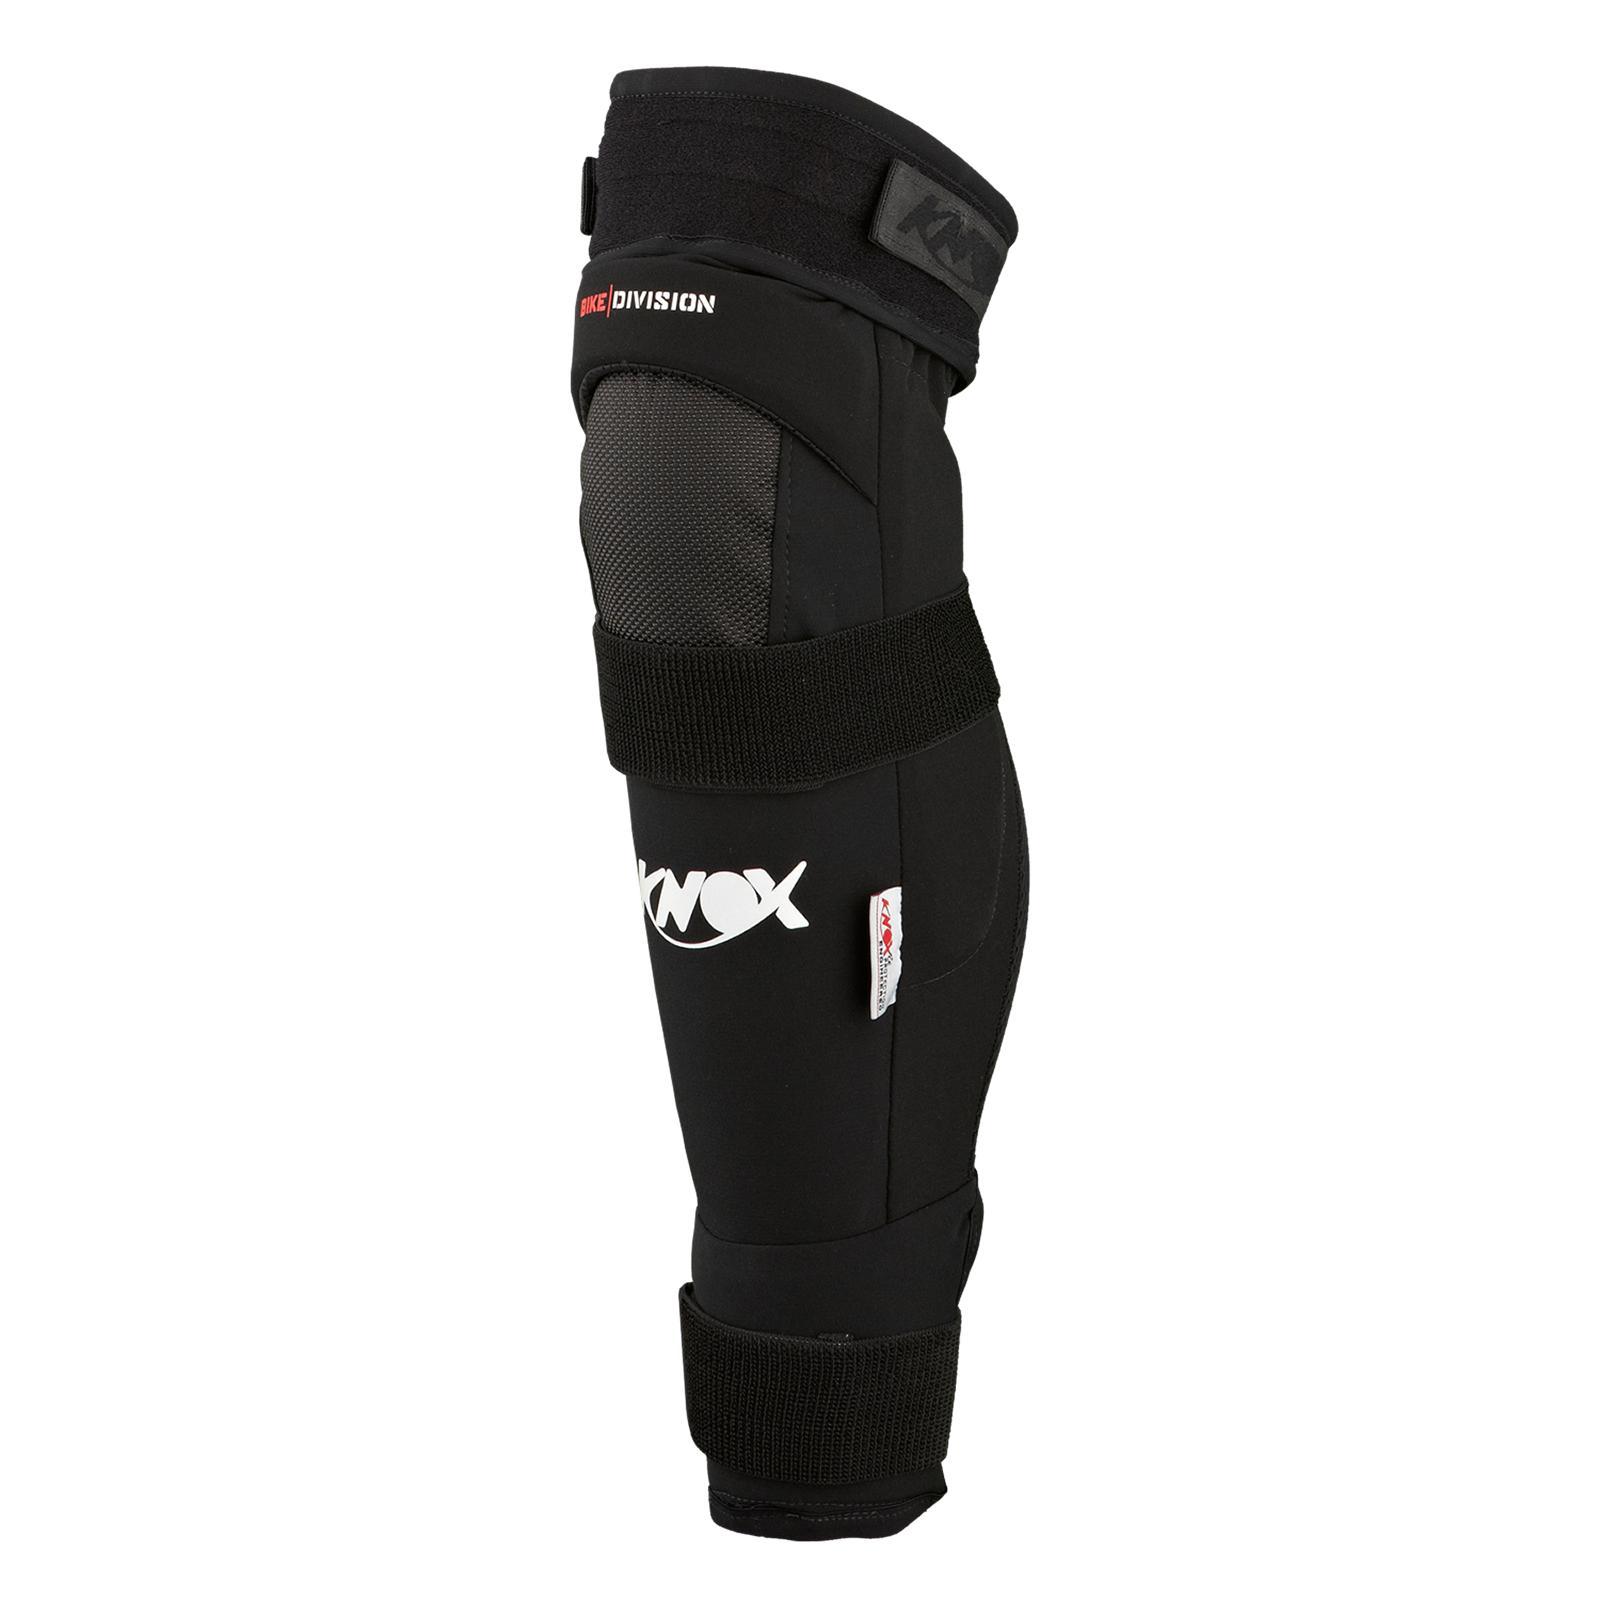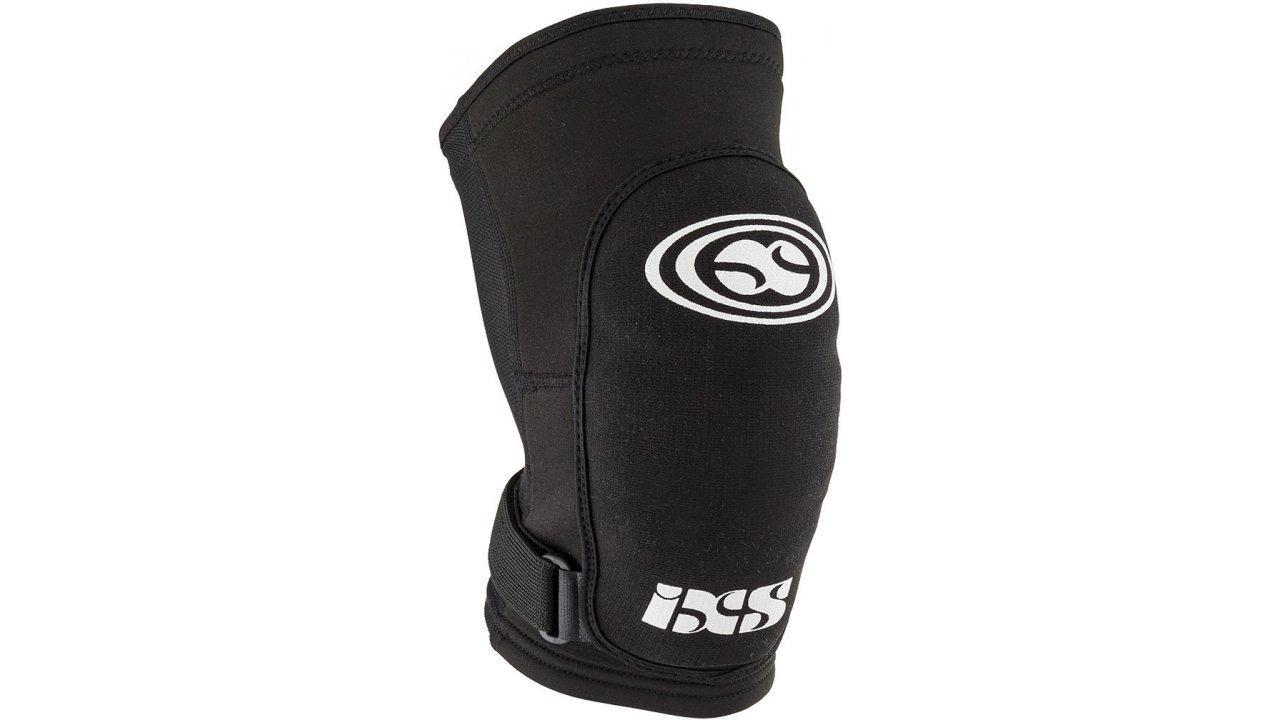The first image is the image on the left, the second image is the image on the right. Analyze the images presented: Is the assertion "The knee braces in the two images face the same direction." valid? Answer yes or no. No. 